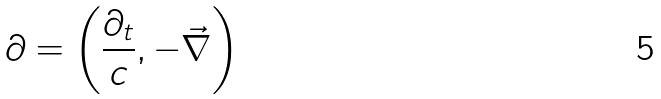<formula> <loc_0><loc_0><loc_500><loc_500>\partial = \left ( { \frac { \partial _ { t } } { c } } , - { \vec { \nabla } } \right )</formula> 